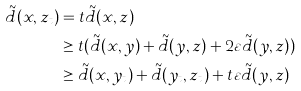<formula> <loc_0><loc_0><loc_500><loc_500>\tilde { d } ( x , z _ { t } ) & = t \tilde { d } ( x , z ) \\ & \geq t ( \tilde { d } ( x , y ) + \tilde { d } ( y , z ) + 2 \varepsilon \tilde { d } ( y , z ) ) \\ & \geq \tilde { d } ( x , y _ { t } ) + \tilde { d } ( y _ { t } , z _ { t } ) + t \varepsilon \tilde { d } ( y , z )</formula> 